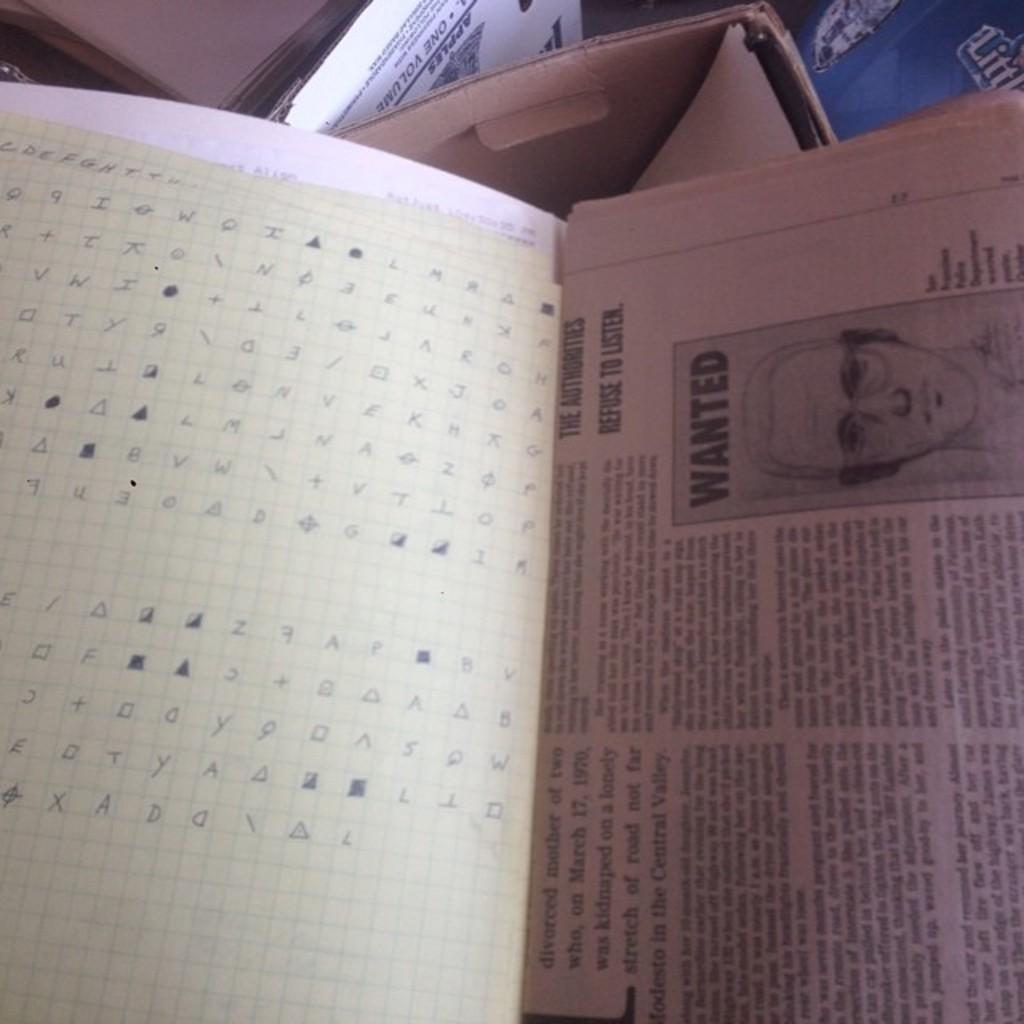<image>
Relay a brief, clear account of the picture shown. A newspaper is open to a page with a wanted poster of a man in glasses. 